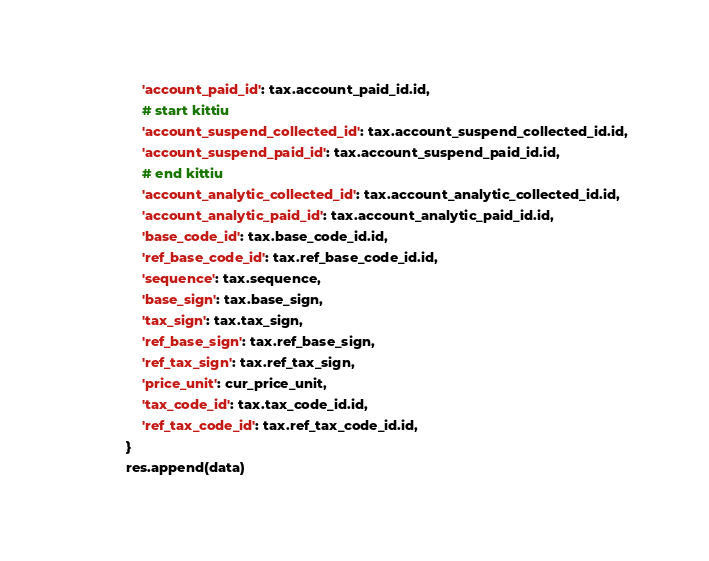Convert code to text. <code><loc_0><loc_0><loc_500><loc_500><_Python_>                'account_paid_id': tax.account_paid_id.id,
                # start kittiu
                'account_suspend_collected_id': tax.account_suspend_collected_id.id,
                'account_suspend_paid_id': tax.account_suspend_paid_id.id,
                # end kittiu
                'account_analytic_collected_id': tax.account_analytic_collected_id.id,
                'account_analytic_paid_id': tax.account_analytic_paid_id.id,
                'base_code_id': tax.base_code_id.id,
                'ref_base_code_id': tax.ref_base_code_id.id,
                'sequence': tax.sequence,
                'base_sign': tax.base_sign,
                'tax_sign': tax.tax_sign,
                'ref_base_sign': tax.ref_base_sign,
                'ref_tax_sign': tax.ref_tax_sign,
                'price_unit': cur_price_unit,
                'tax_code_id': tax.tax_code_id.id,
                'ref_tax_code_id': tax.ref_tax_code_id.id,
            }
            res.append(data)</code> 